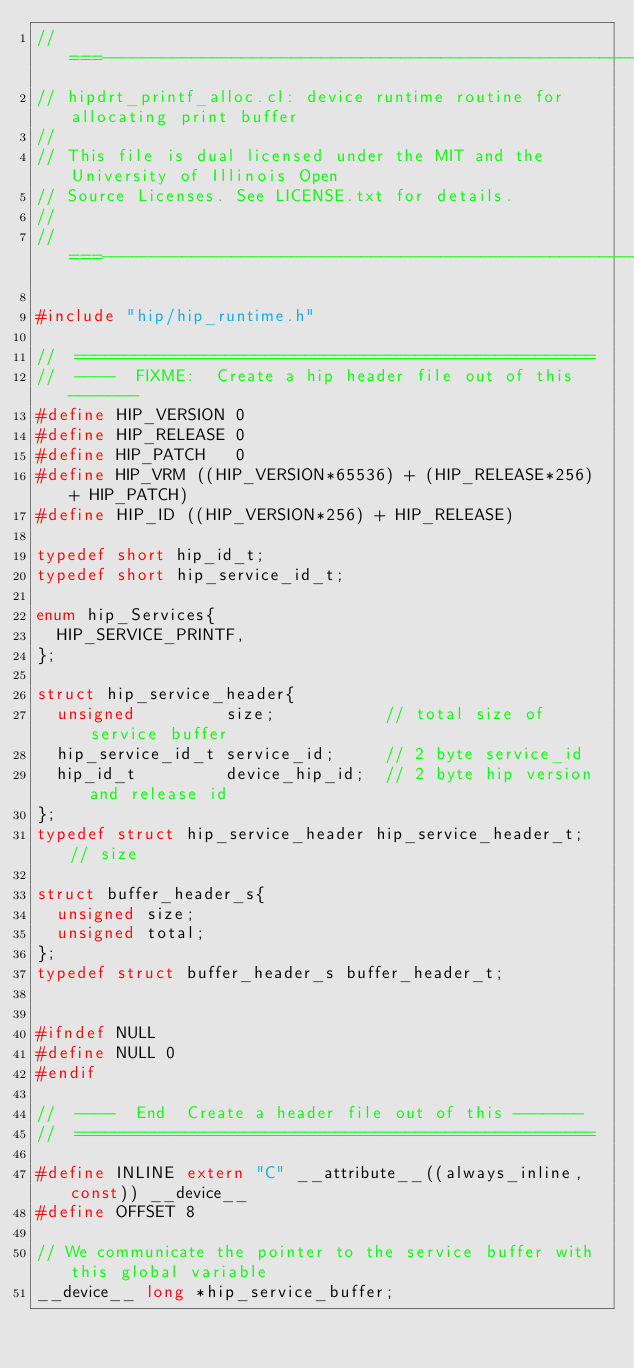Convert code to text. <code><loc_0><loc_0><loc_500><loc_500><_C++_>//===----------------------------------------------------------------------===//
// hipdrt_printf_alloc.cl: device runtime routine for allocating print buffer
//
// This file is dual licensed under the MIT and the University of Illinois Open
// Source Licenses. See LICENSE.txt for details.
//
//===----------------------------------------------------------------------===//

#include "hip/hip_runtime.h"

//  ====================================================
//  ----  FIXME:  Create a hip header file out of this -------
#define HIP_VERSION 0
#define HIP_RELEASE 0
#define HIP_PATCH   0
#define HIP_VRM ((HIP_VERSION*65536) + (HIP_RELEASE*256) + HIP_PATCH)
#define HIP_ID ((HIP_VERSION*256) + HIP_RELEASE)

typedef short hip_id_t;
typedef short hip_service_id_t;

enum hip_Services{
  HIP_SERVICE_PRINTF,
};

struct hip_service_header{
  unsigned         size;           // total size of service buffer
  hip_service_id_t service_id;     // 2 byte service_id
  hip_id_t         device_hip_id;  // 2 byte hip version and release id
};
typedef struct hip_service_header hip_service_header_t; // size 

struct buffer_header_s{
  unsigned size;
  unsigned total;
};
typedef struct buffer_header_s buffer_header_t;


#ifndef NULL
#define NULL 0
#endif

//  ----  End  Create a header file out of this -------
//  ====================================================

#define INLINE extern "C" __attribute__((always_inline,const)) __device__
#define OFFSET 8

// We communicate the pointer to the service buffer with this global variable
__device__ long *hip_service_buffer;
</code> 